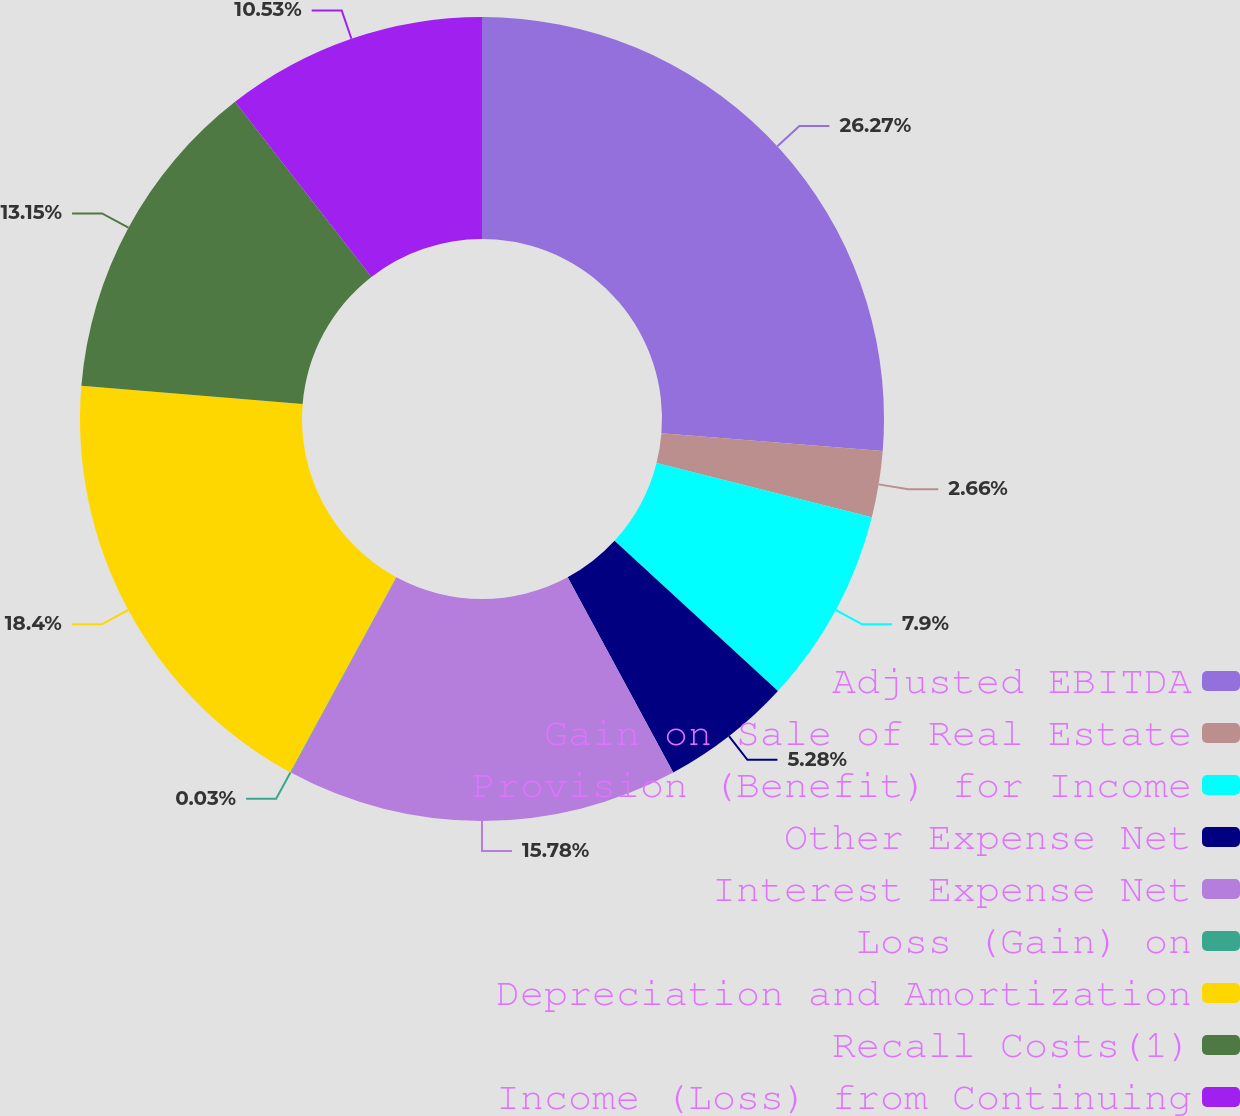Convert chart. <chart><loc_0><loc_0><loc_500><loc_500><pie_chart><fcel>Adjusted EBITDA<fcel>Gain on Sale of Real Estate<fcel>Provision (Benefit) for Income<fcel>Other Expense Net<fcel>Interest Expense Net<fcel>Loss (Gain) on<fcel>Depreciation and Amortization<fcel>Recall Costs(1)<fcel>Income (Loss) from Continuing<nl><fcel>26.27%<fcel>2.66%<fcel>7.9%<fcel>5.28%<fcel>15.78%<fcel>0.03%<fcel>18.4%<fcel>13.15%<fcel>10.53%<nl></chart> 